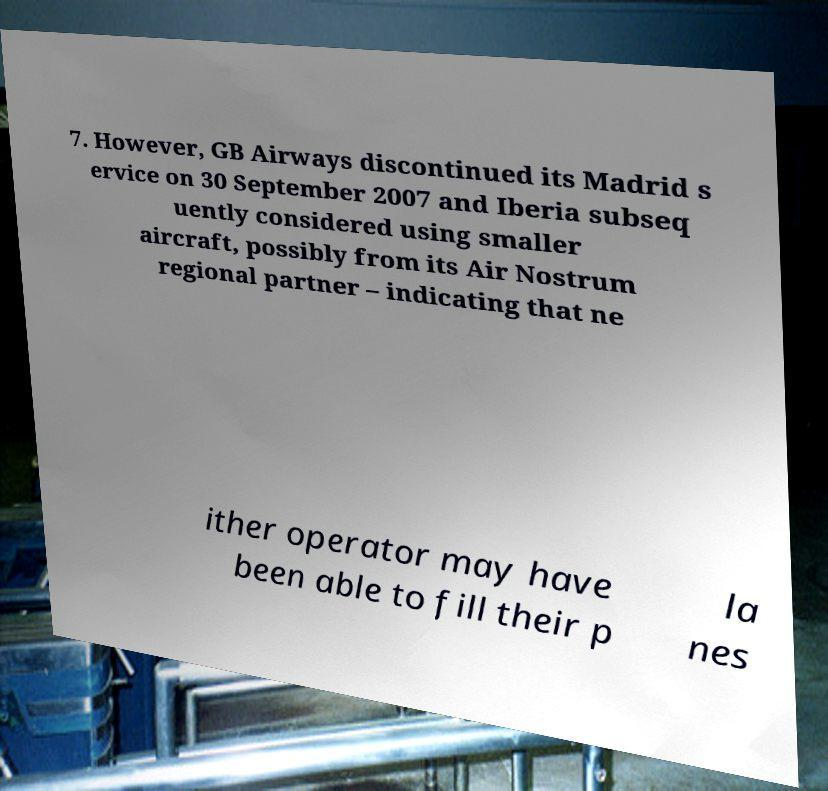What messages or text are displayed in this image? I need them in a readable, typed format. 7. However, GB Airways discontinued its Madrid s ervice on 30 September 2007 and Iberia subseq uently considered using smaller aircraft, possibly from its Air Nostrum regional partner – indicating that ne ither operator may have been able to fill their p la nes 